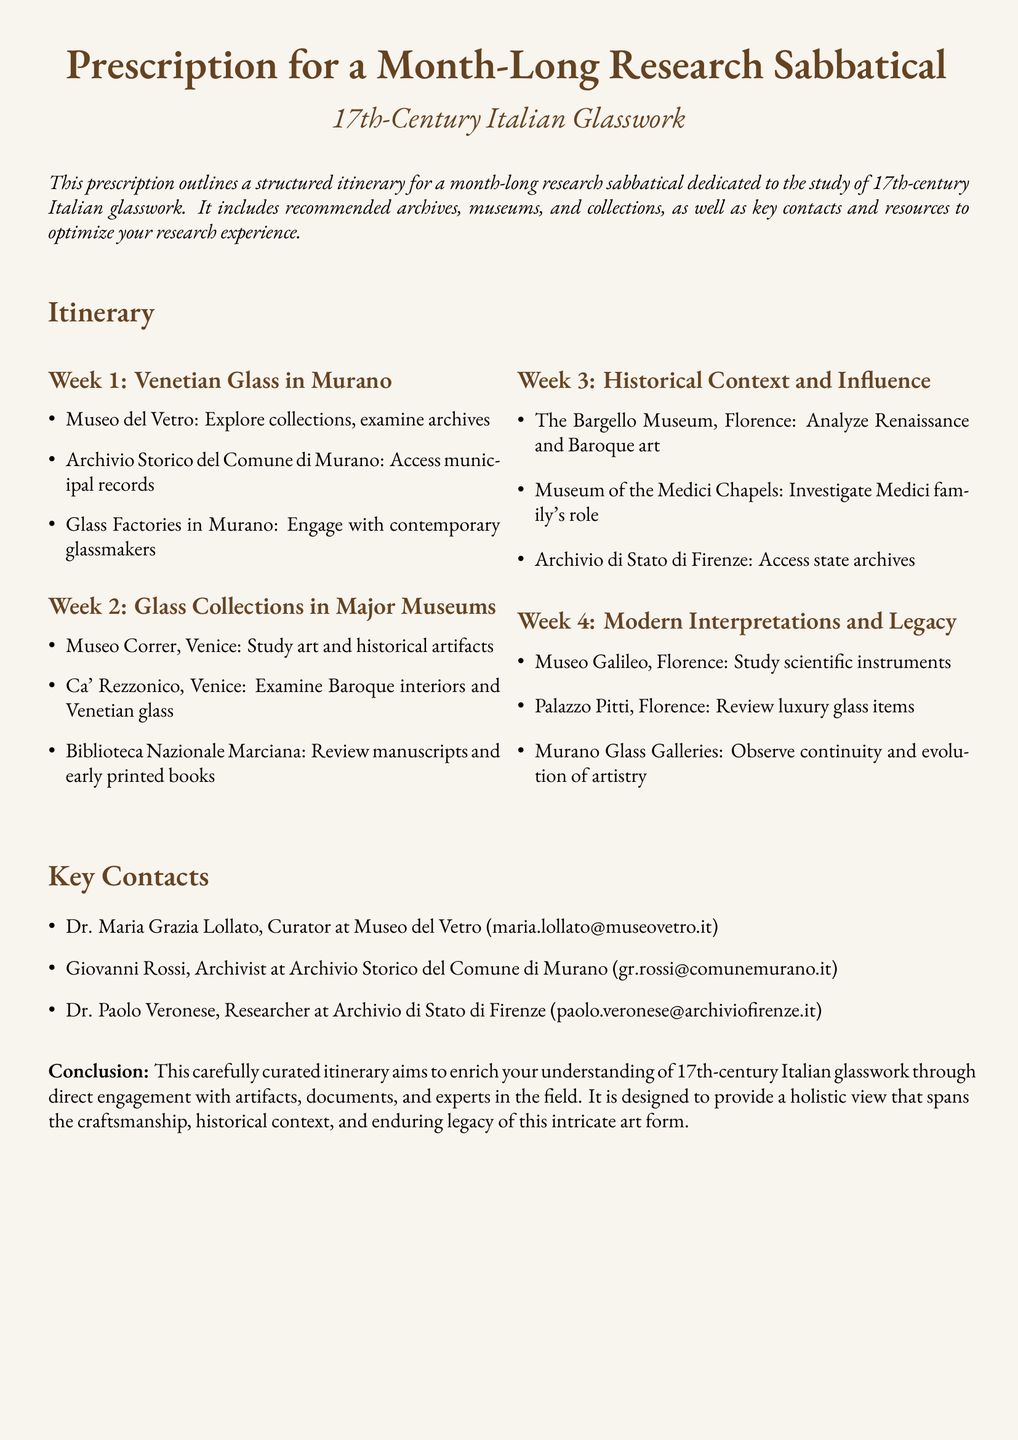What is the focus of the research sabbatical? The document mentions that the focus is on studying 17th-century Italian glasswork.
Answer: 17th-century Italian glasswork Which museum is recommended for studying Venetian glass in Murano? The document lists Museo del Vetro as a recommended museum for this focus.
Answer: Museo del Vetro Who is the curator at Museo del Vetro? The document provides the name of Dr. Maria Grazia Lollato as the curator.
Answer: Dr. Maria Grazia Lollato How many weeks does the sabbatical itinerary span? The document outlines an itinerary that spans four weeks.
Answer: Four weeks What type of items can be reviewed at Palazzo Pitti? The document states that luxury glass items can be reviewed at Palazzo Pitti.
Answer: Luxury glass items Why might studying at the Biblioteca Nazionale Marciana be important? This location allows for the review of manuscripts and early printed books related to the glasswork field.
Answer: Manuscripts and early printed books Which city houses the Bargello Museum? The document specifies that the Bargello Museum is located in Florence.
Answer: Florence What is the primary aim of this carefully curated itinerary? The document states that the aim is to enrich understanding through direct engagement with artifacts, documents, and experts.
Answer: Enrich understanding 